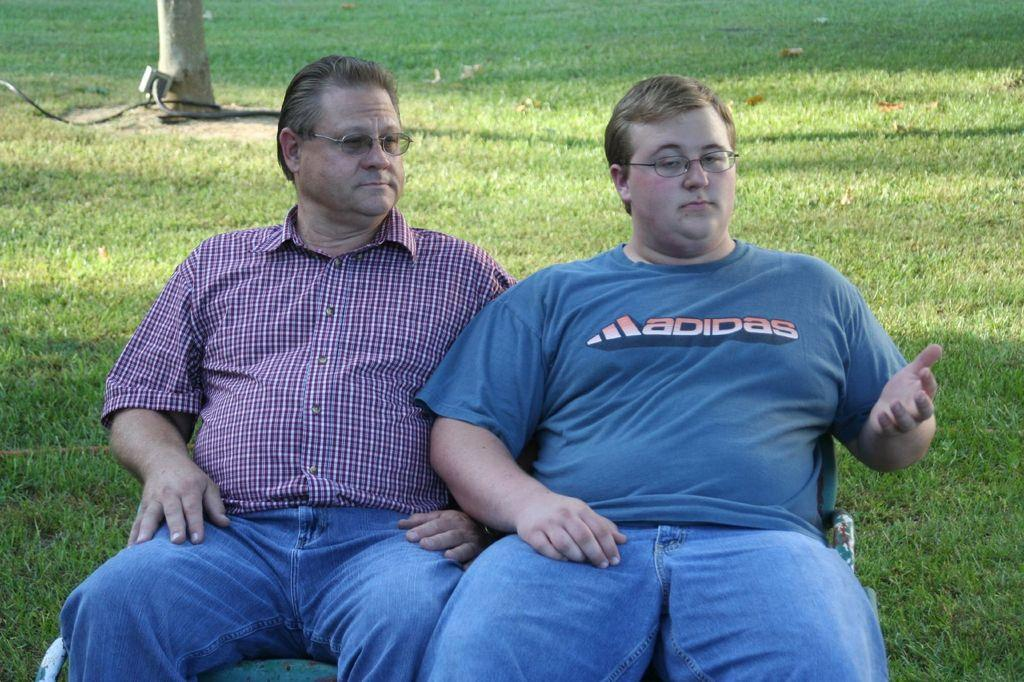How many people are in the image? There are two persons in the image. What can be observed about the persons' appearance? Both persons are wearing spectacles. Can you describe the clothing of one of the persons? One person is wearing a blue t-shirt. What are the persons doing in the image? The persons are sitting on chairs. What can be seen in the background of the image? There is a wire cable and a tree in the background of the image. Where is the kettle located in the image? There is no kettle present in the image. What type of zebra can be seen interacting with the persons in the image? There is no zebra present in the image; only the two persons and their spectacles are visible. 